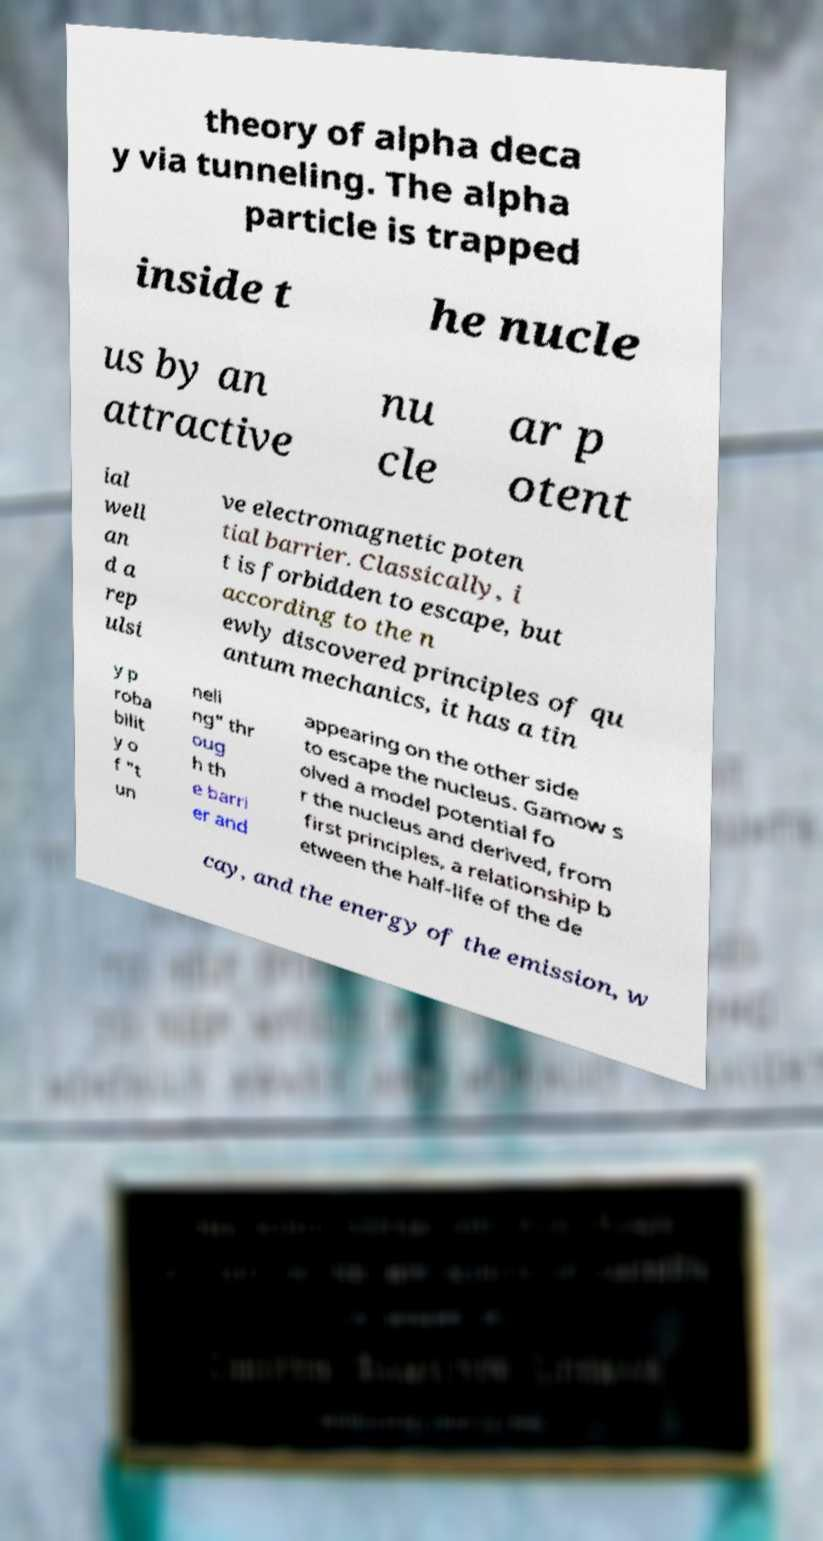What messages or text are displayed in this image? I need them in a readable, typed format. theory of alpha deca y via tunneling. The alpha particle is trapped inside t he nucle us by an attractive nu cle ar p otent ial well an d a rep ulsi ve electromagnetic poten tial barrier. Classically, i t is forbidden to escape, but according to the n ewly discovered principles of qu antum mechanics, it has a tin y p roba bilit y o f "t un neli ng" thr oug h th e barri er and appearing on the other side to escape the nucleus. Gamow s olved a model potential fo r the nucleus and derived, from first principles, a relationship b etween the half-life of the de cay, and the energy of the emission, w 